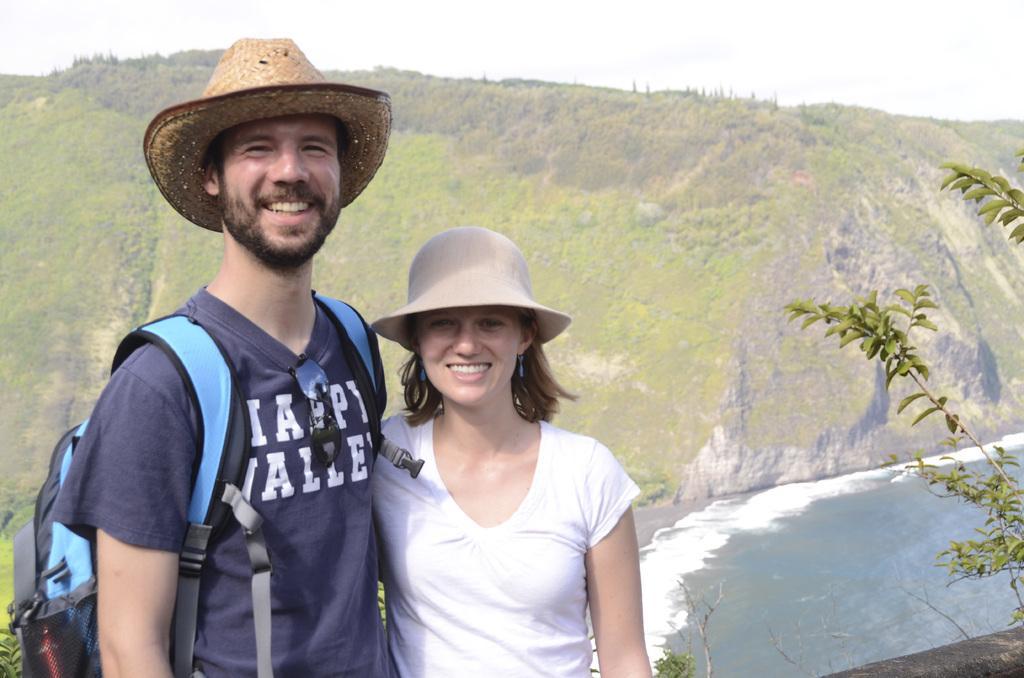In one or two sentences, can you explain what this image depicts? In this picture there are two people standing and smiling. At the back there are trees on the mountain. At the top there is sky. On the right side of the image there is a tree and there is a wall. At the bottom there is water. 